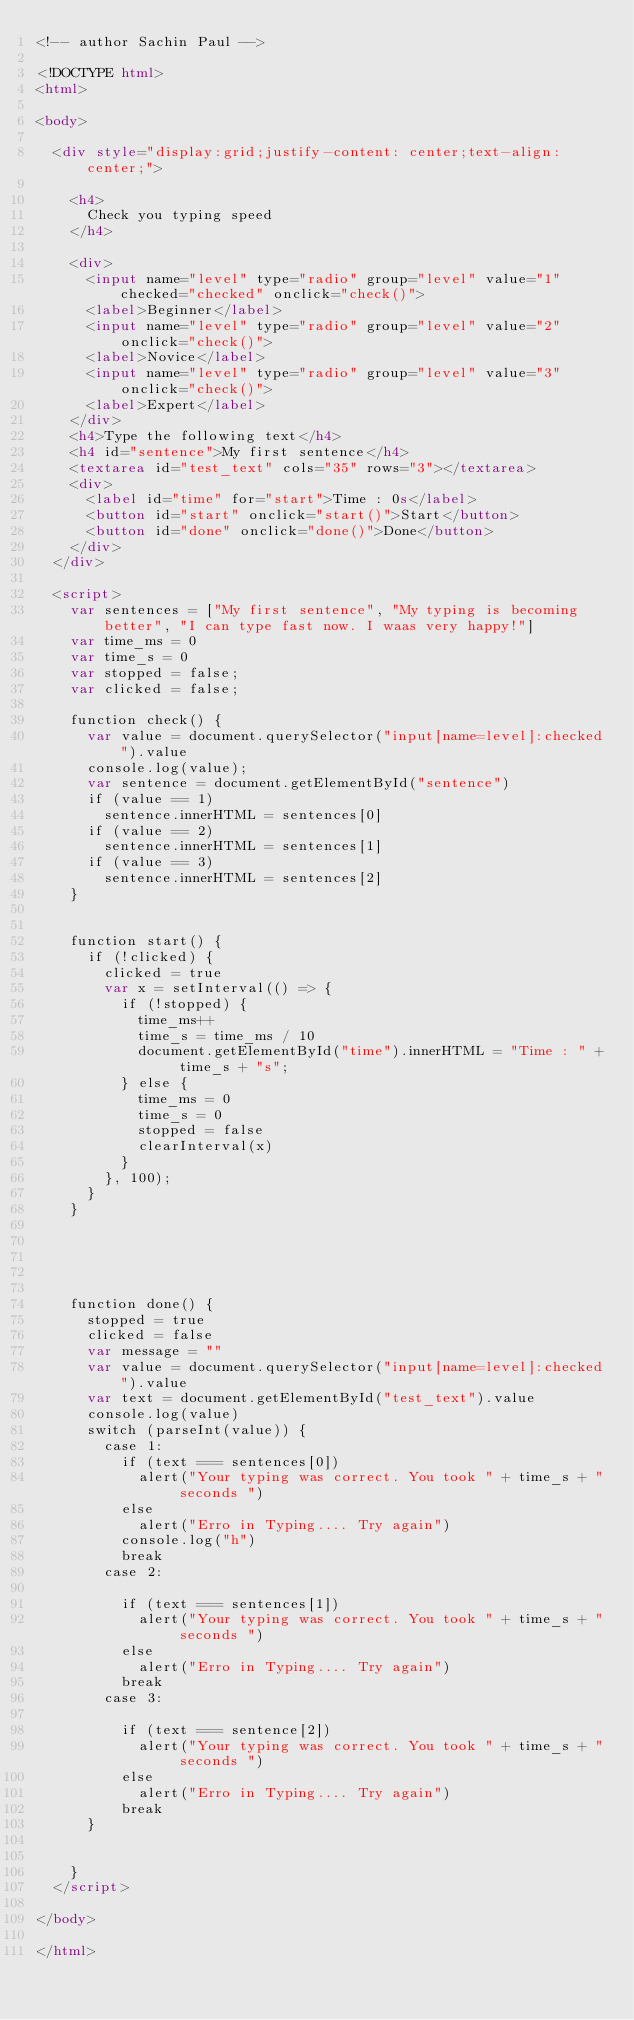Convert code to text. <code><loc_0><loc_0><loc_500><loc_500><_HTML_><!-- author Sachin Paul -->

<!DOCTYPE html>
<html>

<body>

	<div style="display:grid;justify-content: center;text-align: center;">

		<h4>
			Check you typing speed
		</h4>

		<div>
			<input name="level" type="radio" group="level" value="1" checked="checked" onclick="check()">
			<label>Beginner</label>
			<input name="level" type="radio" group="level" value="2" onclick="check()">
			<label>Novice</label>
			<input name="level" type="radio" group="level" value="3" onclick="check()">
			<label>Expert</label>
		</div>
		<h4>Type the following text</h4>
		<h4 id="sentence">My first sentence</h4>
		<textarea id="test_text" cols="35" rows="3"></textarea>
		<div>
			<label id="time" for="start">Time : 0s</label>
			<button id="start" onclick="start()">Start</button>
			<button id="done" onclick="done()">Done</button>
		</div>
	</div>

	<script>
		var sentences = ["My first sentence", "My typing is becoming better", "I can type fast now. I waas very happy!"]
		var time_ms = 0
		var time_s = 0
		var stopped = false;
		var clicked = false;

		function check() {
			var value = document.querySelector("input[name=level]:checked").value
			console.log(value);
			var sentence = document.getElementById("sentence")
			if (value == 1)
				sentence.innerHTML = sentences[0]
			if (value == 2)
				sentence.innerHTML = sentences[1]
			if (value == 3)
				sentence.innerHTML = sentences[2]
		}


		function start() {
			if (!clicked) {
				clicked = true
				var x = setInterval(() => {
					if (!stopped) {
						time_ms++
						time_s = time_ms / 10
						document.getElementById("time").innerHTML = "Time : " + time_s + "s";
					} else {
						time_ms = 0
						time_s = 0
						stopped = false
						clearInterval(x)
					}
				}, 100);
			}
		}





		function done() {
			stopped = true
			clicked = false
			var message = ""
			var value = document.querySelector("input[name=level]:checked").value
			var text = document.getElementById("test_text").value
			console.log(value)
			switch (parseInt(value)) {
				case 1:
					if (text === sentences[0])
						alert("Your typing was correct. You took " + time_s + " seconds ")
					else
						alert("Erro in Typing.... Try again")
					console.log("h")
					break
				case 2:

					if (text === sentences[1])
						alert("Your typing was correct. You took " + time_s + " seconds ")
					else
						alert("Erro in Typing.... Try again")
					break
				case 3:

					if (text === sentence[2])
						alert("Your typing was correct. You took " + time_s + " seconds ")
					else
						alert("Erro in Typing.... Try again")
					break
			}


		}
	</script>

</body>

</html>
</code> 